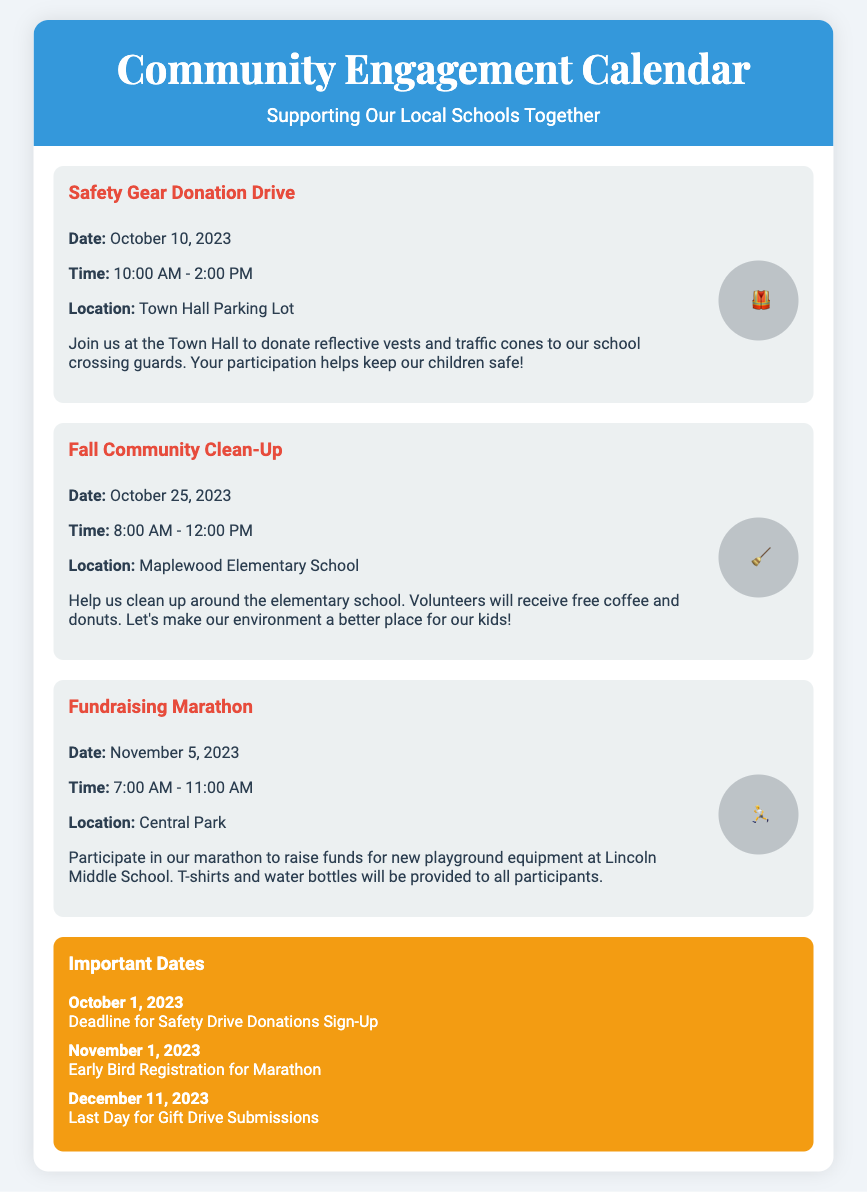What is the title of the first event? The title of the first event is provided in the events section of the document, which states "Safety Gear Donation Drive."
Answer: Safety Gear Donation Drive What is the date of the Fall Community Clean-Up? The date for the Fall Community Clean-Up is directly mentioned in the event details, which shows "October 25, 2023."
Answer: October 25, 2023 Where will the Fundraising Marathon take place? The location of the Fundraising Marathon is found in the event details, which indicates it takes place at "Central Park."
Answer: Central Park What item will volunteers receive at the Fall Community Clean-Up? The document specifies that volunteers will receive "free coffee and donuts" for their participation at the clean-up event.
Answer: free coffee and donuts What is the deadline for Safety Drive Donations Sign-Up? The deadline for Safety Drive Donations Sign-Up is mentioned under Important Dates as "October 1, 2023."
Answer: October 1, 2023 How many events are listed in the Community Engagement Calendar? The document lists three events in total under the events section.
Answer: three What is the time frame for the Safety Gear Donation Drive? The time frame is clearly outlined in the event details, stating "10:00 AM - 2:00 PM."
Answer: 10:00 AM - 2:00 PM What is the purpose of the Fundraising Marathon? The document states that the purpose is to "raise funds for new playground equipment at Lincoln Middle School."
Answer: raise funds for new playground equipment How are the important dates presented in the document? The important dates are presented in a dedicated section labeled "Important Dates" and are formatted in a clear list.
Answer: as a dedicated section 